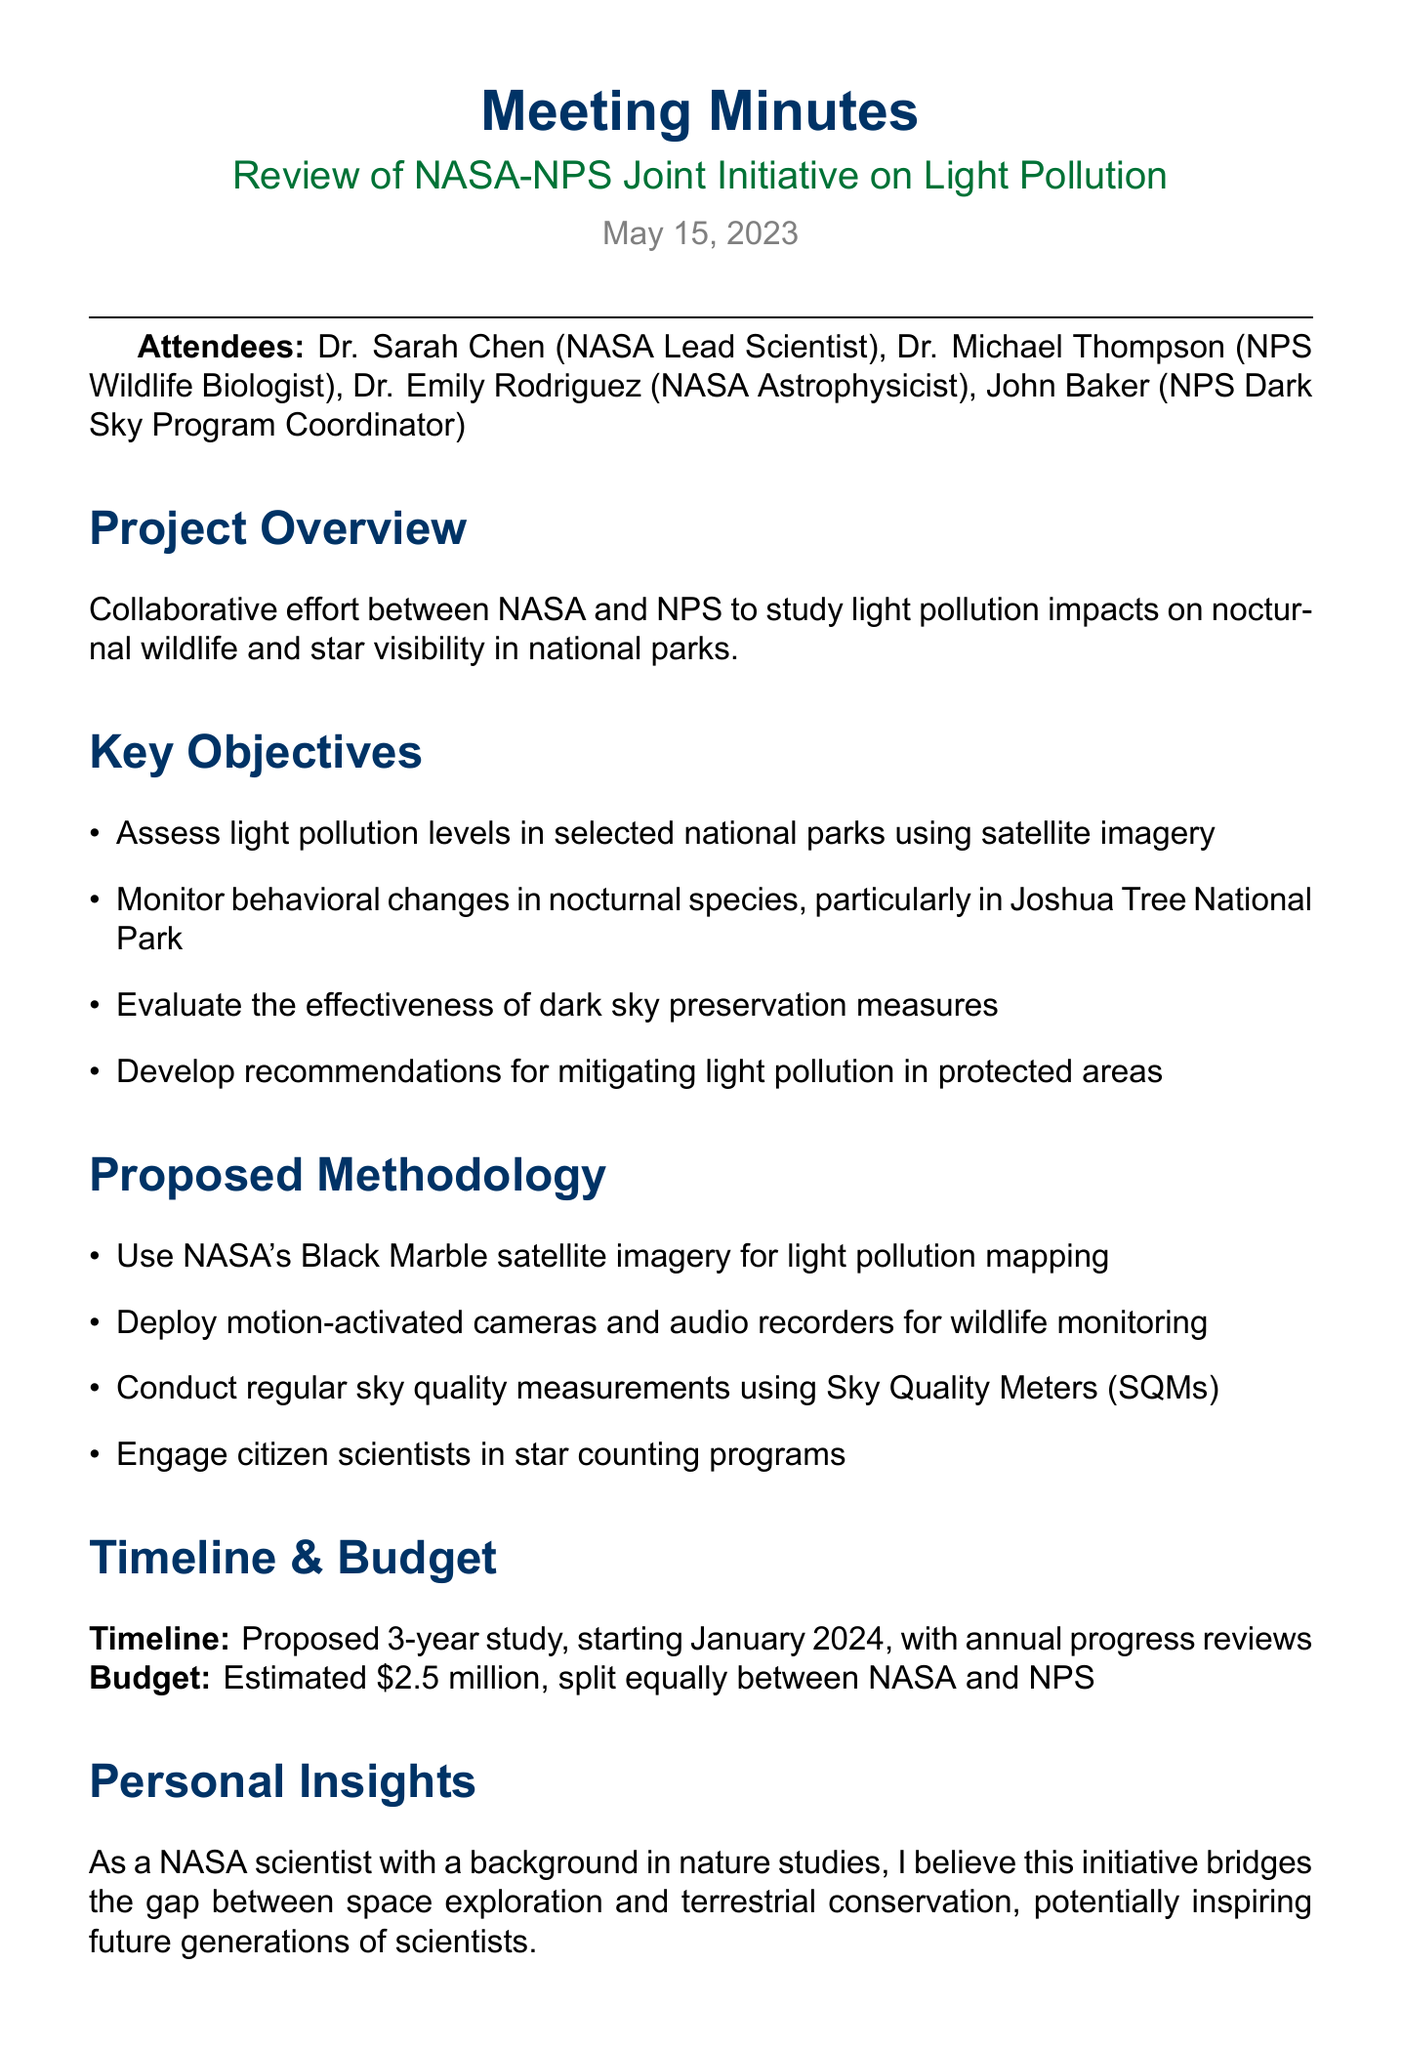What is the date of the meeting? The date of the meeting is explicitly mentioned in the document.
Answer: May 15, 2023 Who are the attendees? The attendees section lists all the individuals present during the meeting.
Answer: Dr. Sarah Chen, Dr. Michael Thompson, Dr. Emily Rodriguez, John Baker What is the budget for the initiative? The budget estimation is provided in the budget considerations section of the document.
Answer: $2.5 million What is one method proposed for wildlife monitoring? The proposed methodology includes various methods for monitoring wildlife, one of which is specified.
Answer: Deploy motion-activated cameras What year is the study proposed to start? The timeline section indicates when the study is scheduled to begin.
Answer: January 2024 What is the key objective related to Joshua Tree National Park? The key objectives section identifies a specific park and type of monitoring planned.
Answer: Monitor behavioral changes in nocturnal species How long is the proposed study? The timeline section provides the duration of the study.
Answer: 3 years What type of outreach materials are to be prepared? The next steps section describes the kind of materials that will be developed.
Answer: Public outreach materials What is Dr. Sarah Chen's personal insight about the initiative? The personal insights section reflects on Dr. Chen's beliefs regarding the initiative's importance.
Answer: Bridges the gap between space exploration and terrestrial conservation 